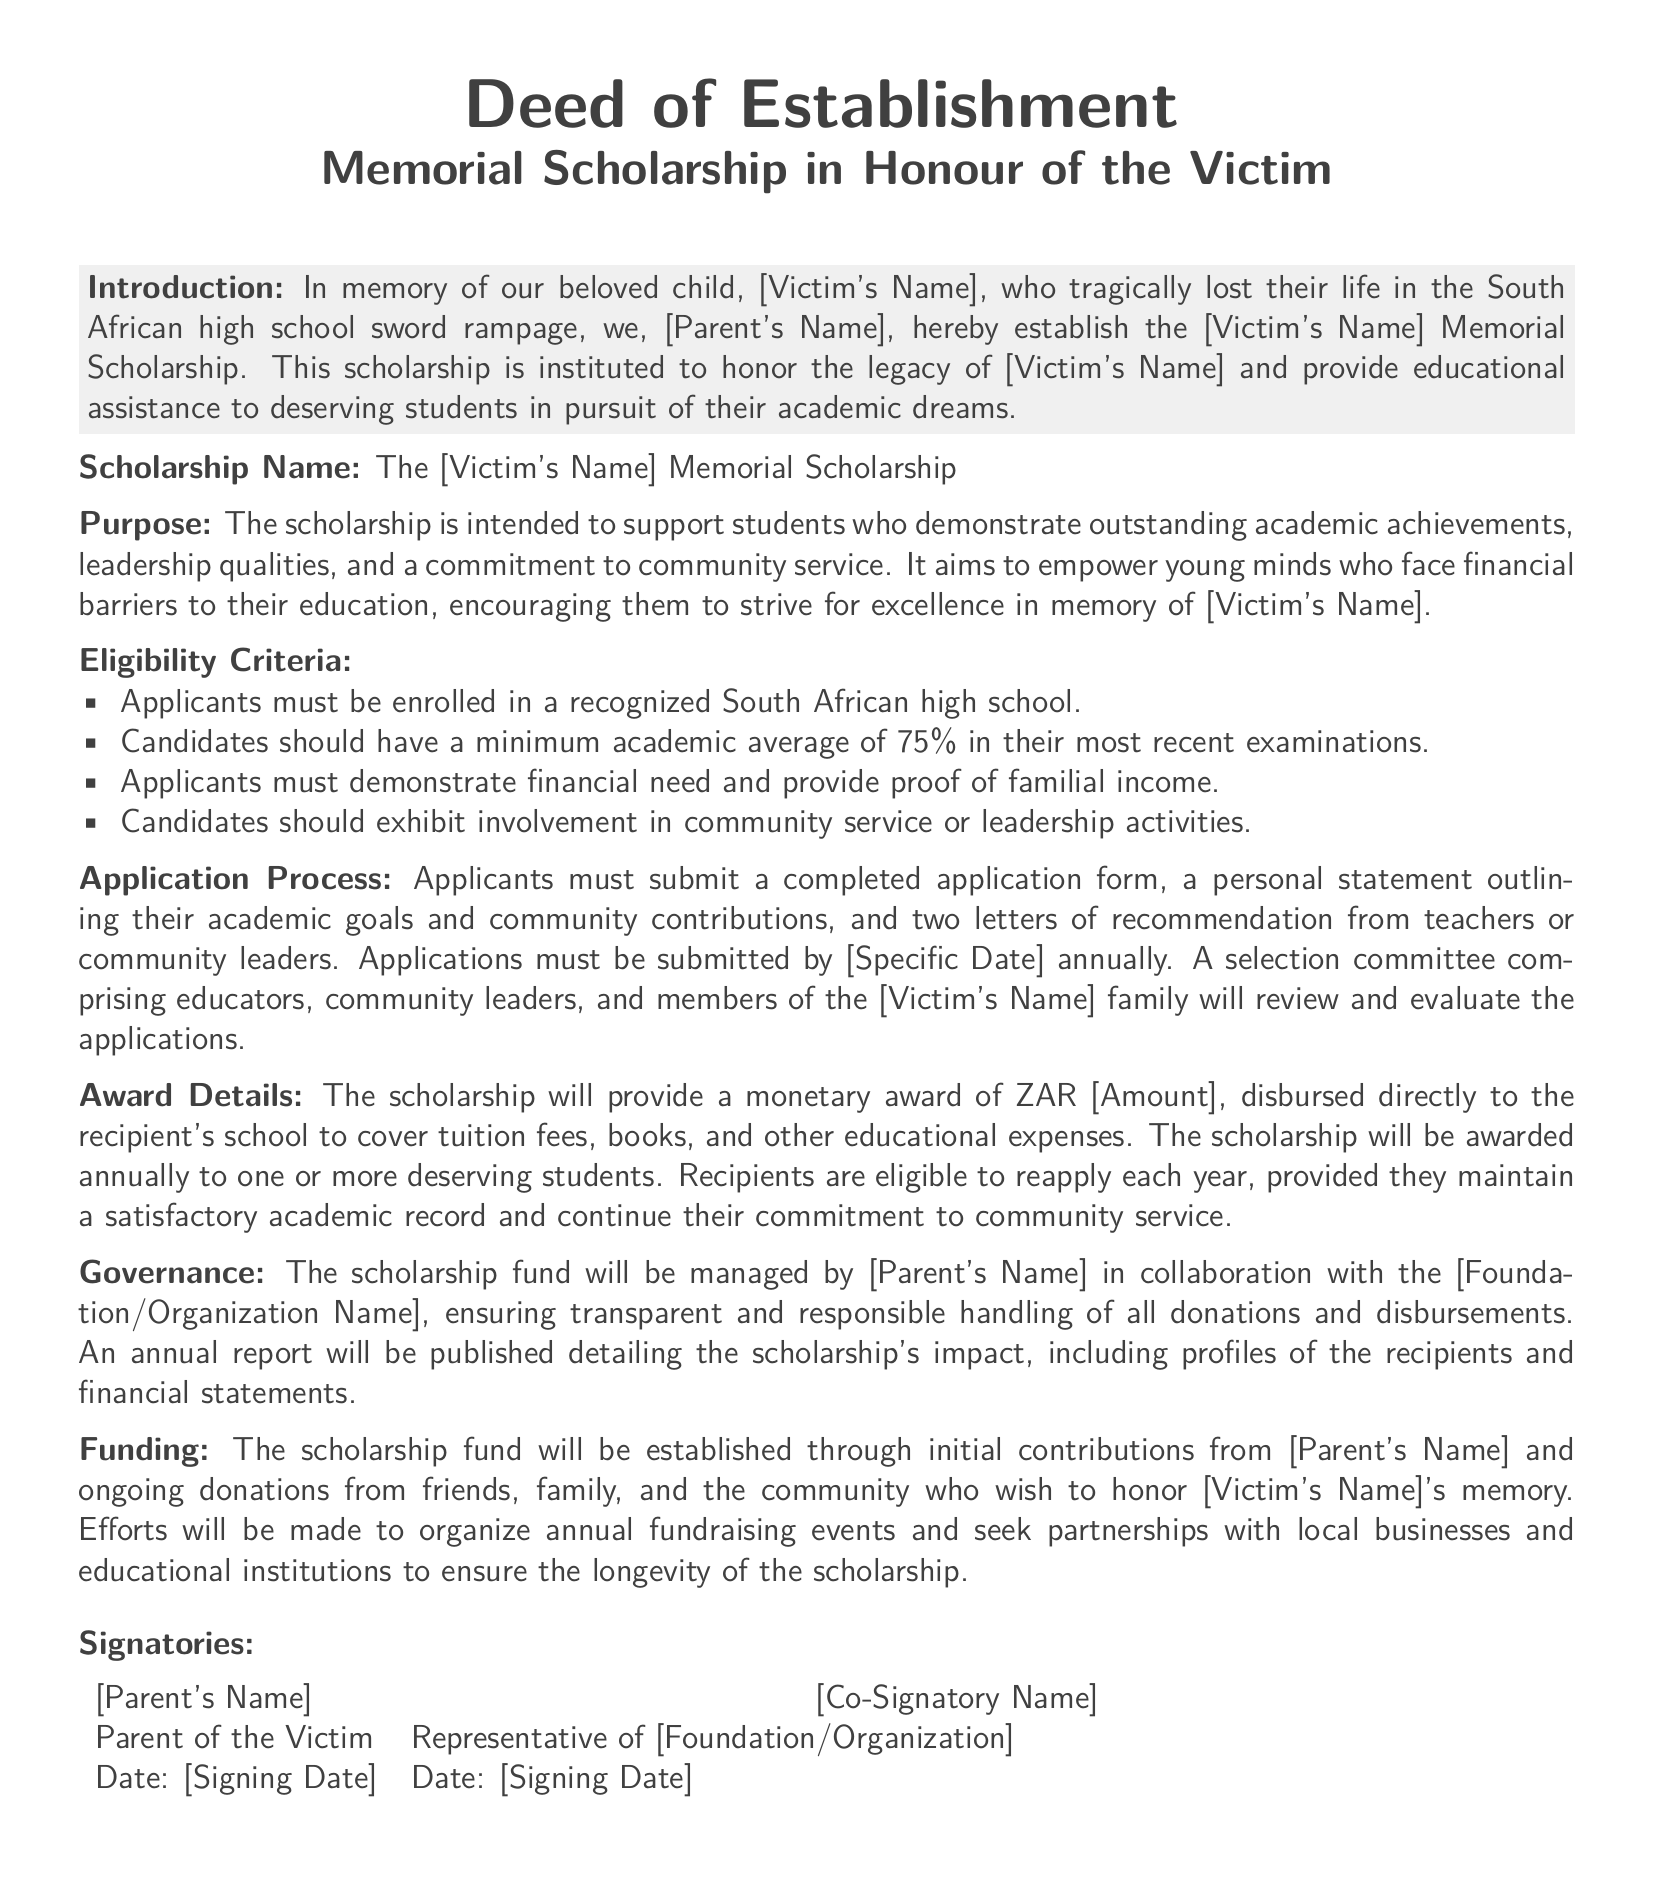What is the name of the scholarship? The scholarship is called the [Victim's Name] Memorial Scholarship as stated in the document.
Answer: [Victim's Name] Memorial Scholarship What is the minimum academic average required? The document specifies that candidates should have a minimum academic average of 75% in their most recent examinations.
Answer: 75% Who manages the scholarship fund? The scholarship fund will be managed by [Parent's Name] in collaboration with the [Foundation/Organization Name].
Answer: [Parent's Name] What is the purpose of the scholarship? The scholarship is intended to support students who demonstrate outstanding academic achievements, leadership qualities, and a commitment to community service.
Answer: Support deserving students What must applicants submit for their application? Applicants must submit a completed application form, a personal statement, and two letters of recommendation.
Answer: Application form, personal statement, two letters of recommendation What is the monetary award amount? The document states that the scholarship will provide a monetary award of ZAR [Amount].
Answer: ZAR [Amount] How often will the scholarship be awarded? The scholarship will be awarded annually to one or more deserving students.
Answer: Annually What is required for recipients to reapply? Recipients are eligible to reapply each year provided they maintain a satisfactory academic record and continue their commitment to community service.
Answer: Satisfactory academic record When must applications be submitted? Applications must be submitted by [Specific Date] annually.
Answer: [Specific Date] 